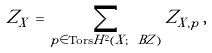Convert formula to latex. <formula><loc_0><loc_0><loc_500><loc_500>Z _ { X } \, = \, \sum _ { p \in \text {Tors} H ^ { 2 } ( X ; \ B Z ) } Z _ { X , p } \, ,</formula> 